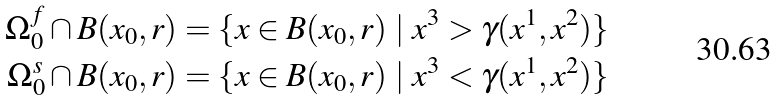Convert formula to latex. <formula><loc_0><loc_0><loc_500><loc_500>\Omega ^ { f } _ { 0 } \cap B ( x _ { 0 } , r ) & = \{ x \in B ( x _ { 0 } , r ) \ | \ x ^ { 3 } > \gamma ( x ^ { 1 } , x ^ { 2 } ) \} \\ \Omega ^ { s } _ { 0 } \cap B ( x _ { 0 } , r ) & = \{ x \in B ( x _ { 0 } , r ) \ | \ x ^ { 3 } < \gamma ( x ^ { 1 } , x ^ { 2 } ) \} \\</formula> 